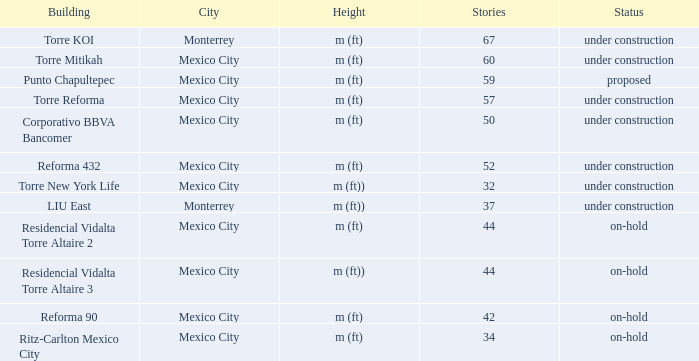What is the status of the torre reforma building that is over 44 stories in mexico city? Under construction. 